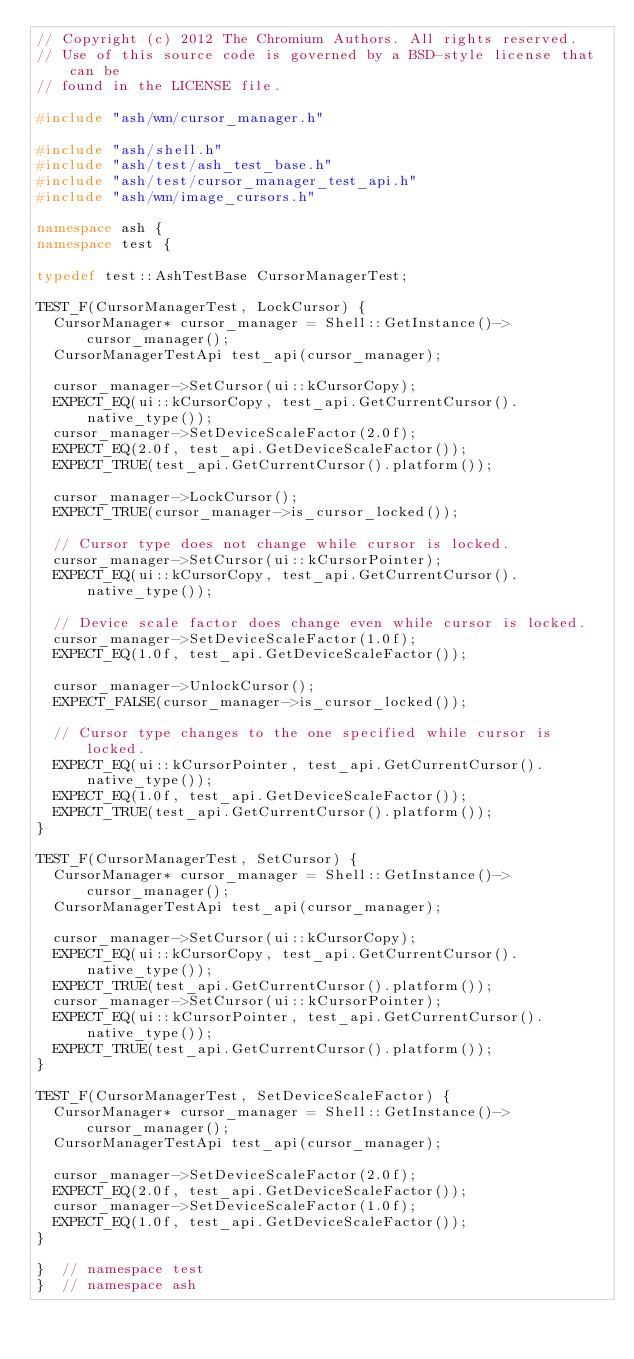<code> <loc_0><loc_0><loc_500><loc_500><_C++_>// Copyright (c) 2012 The Chromium Authors. All rights reserved.
// Use of this source code is governed by a BSD-style license that can be
// found in the LICENSE file.

#include "ash/wm/cursor_manager.h"

#include "ash/shell.h"
#include "ash/test/ash_test_base.h"
#include "ash/test/cursor_manager_test_api.h"
#include "ash/wm/image_cursors.h"

namespace ash {
namespace test {

typedef test::AshTestBase CursorManagerTest;

TEST_F(CursorManagerTest, LockCursor) {
  CursorManager* cursor_manager = Shell::GetInstance()->cursor_manager();
  CursorManagerTestApi test_api(cursor_manager);

  cursor_manager->SetCursor(ui::kCursorCopy);
  EXPECT_EQ(ui::kCursorCopy, test_api.GetCurrentCursor().native_type());
  cursor_manager->SetDeviceScaleFactor(2.0f);
  EXPECT_EQ(2.0f, test_api.GetDeviceScaleFactor());
  EXPECT_TRUE(test_api.GetCurrentCursor().platform());

  cursor_manager->LockCursor();
  EXPECT_TRUE(cursor_manager->is_cursor_locked());

  // Cursor type does not change while cursor is locked.
  cursor_manager->SetCursor(ui::kCursorPointer);
  EXPECT_EQ(ui::kCursorCopy, test_api.GetCurrentCursor().native_type());

  // Device scale factor does change even while cursor is locked.
  cursor_manager->SetDeviceScaleFactor(1.0f);
  EXPECT_EQ(1.0f, test_api.GetDeviceScaleFactor());

  cursor_manager->UnlockCursor();
  EXPECT_FALSE(cursor_manager->is_cursor_locked());

  // Cursor type changes to the one specified while cursor is locked.
  EXPECT_EQ(ui::kCursorPointer, test_api.GetCurrentCursor().native_type());
  EXPECT_EQ(1.0f, test_api.GetDeviceScaleFactor());
  EXPECT_TRUE(test_api.GetCurrentCursor().platform());
}

TEST_F(CursorManagerTest, SetCursor) {
  CursorManager* cursor_manager = Shell::GetInstance()->cursor_manager();
  CursorManagerTestApi test_api(cursor_manager);

  cursor_manager->SetCursor(ui::kCursorCopy);
  EXPECT_EQ(ui::kCursorCopy, test_api.GetCurrentCursor().native_type());
  EXPECT_TRUE(test_api.GetCurrentCursor().platform());
  cursor_manager->SetCursor(ui::kCursorPointer);
  EXPECT_EQ(ui::kCursorPointer, test_api.GetCurrentCursor().native_type());
  EXPECT_TRUE(test_api.GetCurrentCursor().platform());
}

TEST_F(CursorManagerTest, SetDeviceScaleFactor) {
  CursorManager* cursor_manager = Shell::GetInstance()->cursor_manager();
  CursorManagerTestApi test_api(cursor_manager);

  cursor_manager->SetDeviceScaleFactor(2.0f);
  EXPECT_EQ(2.0f, test_api.GetDeviceScaleFactor());
  cursor_manager->SetDeviceScaleFactor(1.0f);
  EXPECT_EQ(1.0f, test_api.GetDeviceScaleFactor());
}

}  // namespace test
}  // namespace ash
</code> 